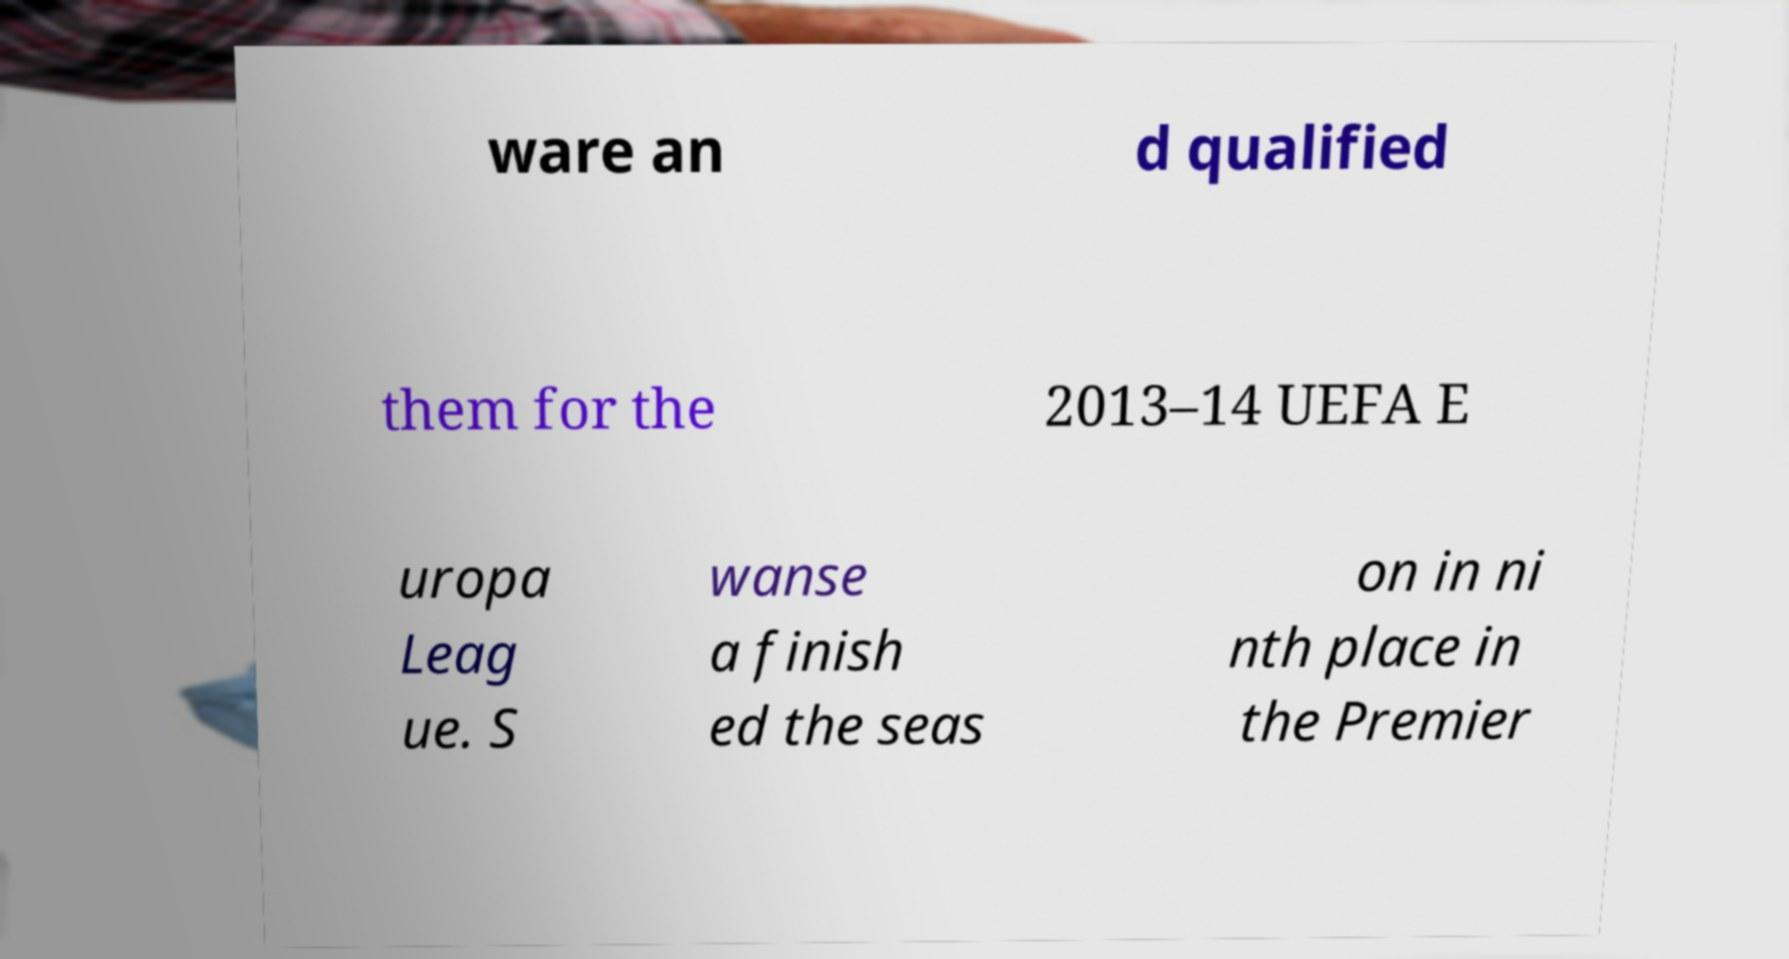There's text embedded in this image that I need extracted. Can you transcribe it verbatim? ware an d qualified them for the 2013–14 UEFA E uropa Leag ue. S wanse a finish ed the seas on in ni nth place in the Premier 